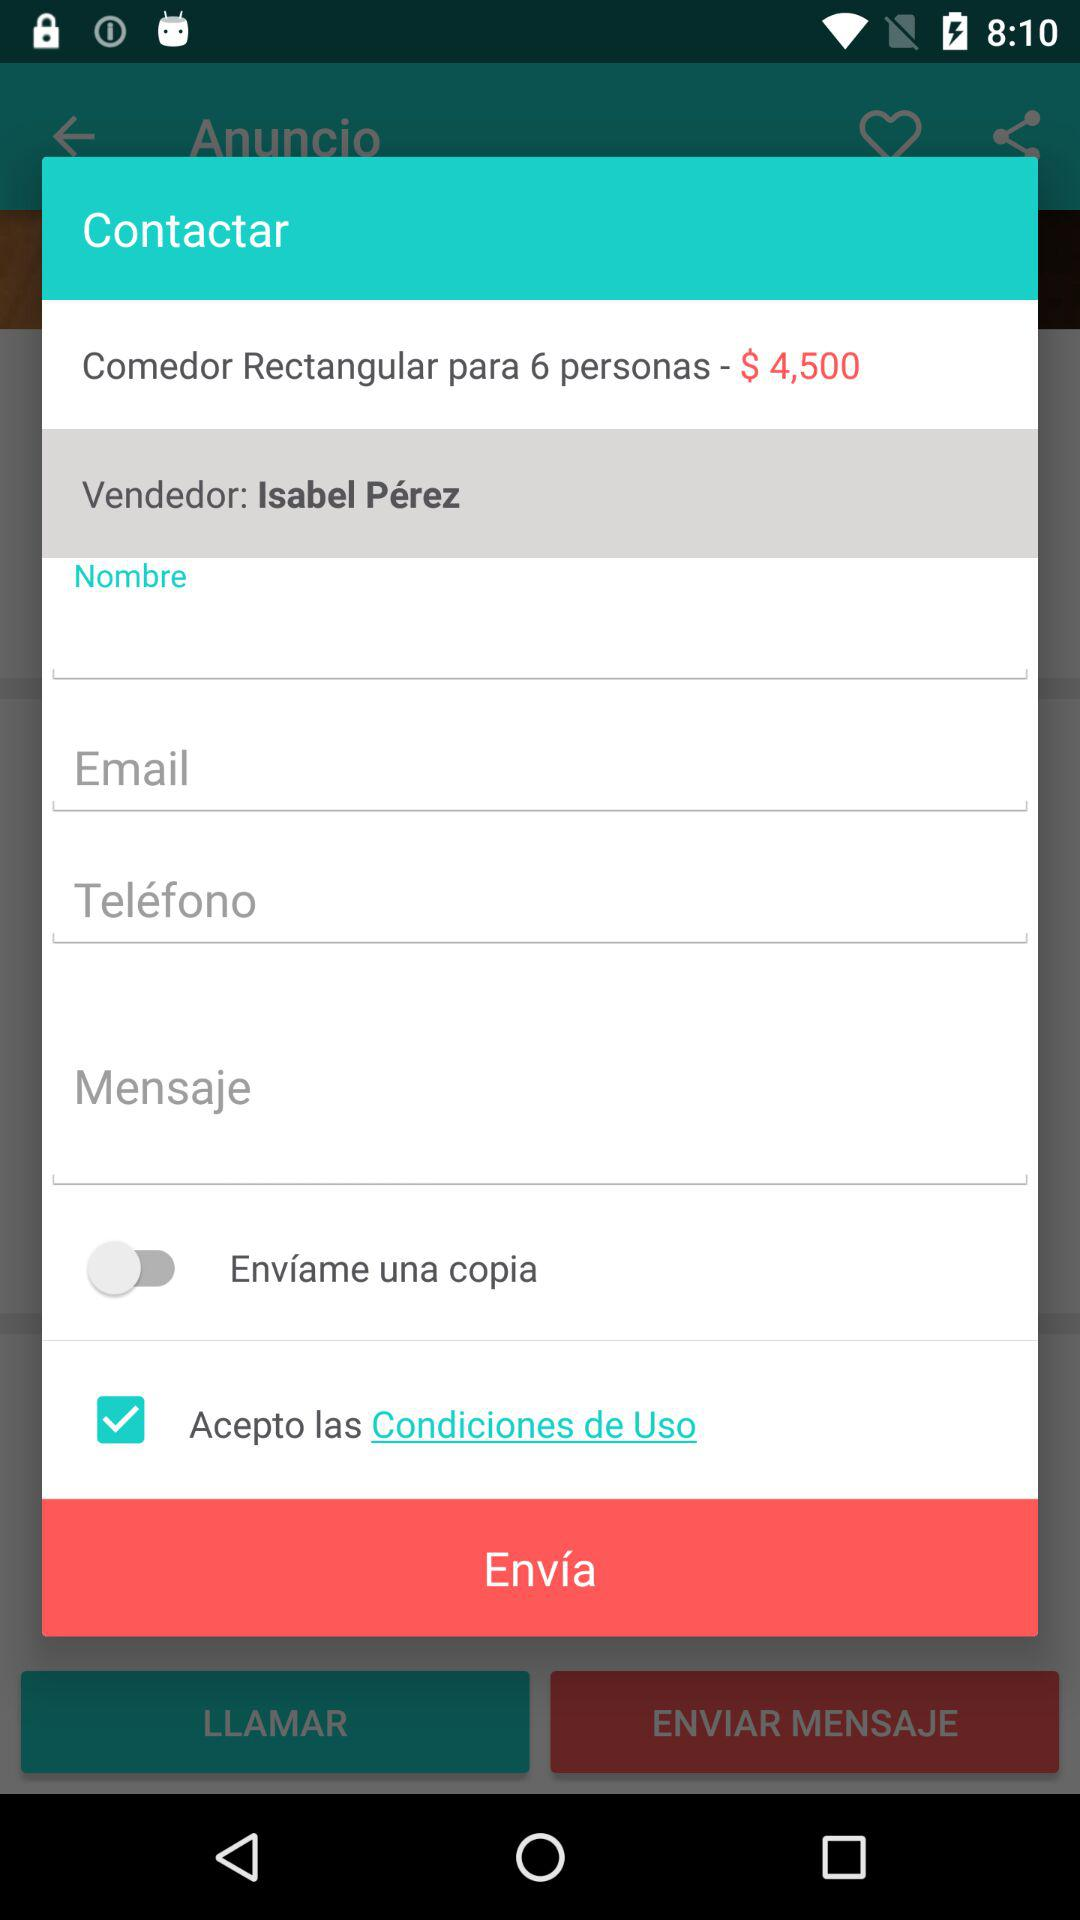How many text fields are there in this contact form?
Answer the question using a single word or phrase. 4 